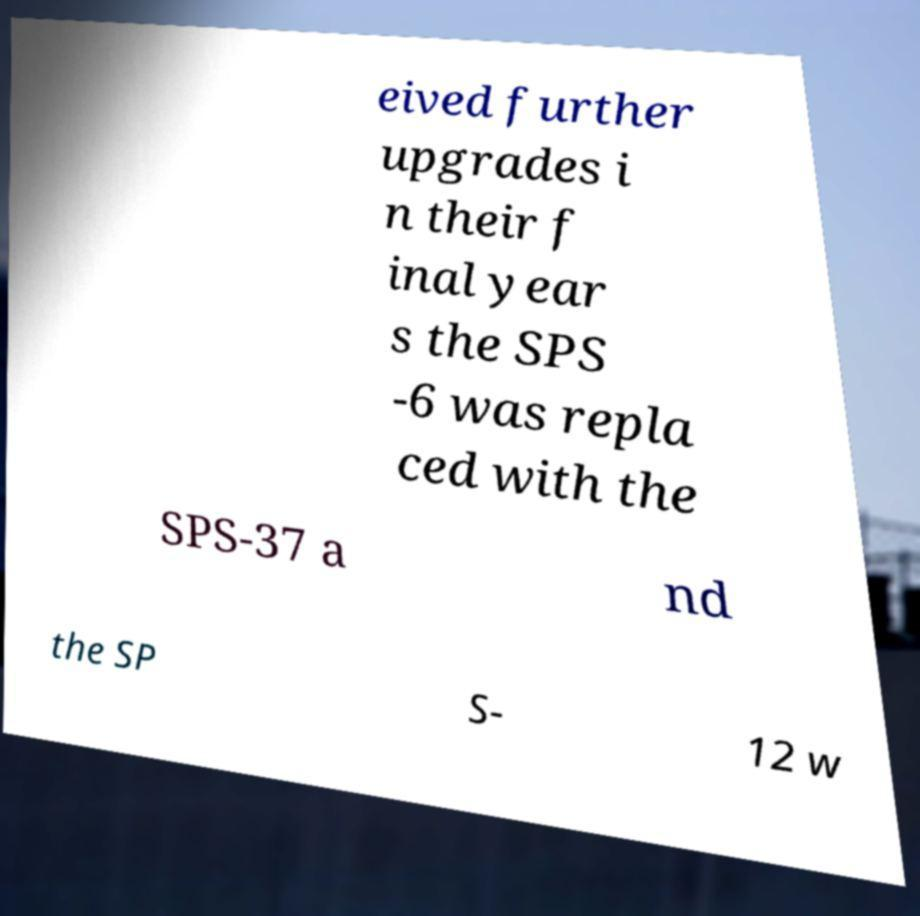Could you assist in decoding the text presented in this image and type it out clearly? eived further upgrades i n their f inal year s the SPS -6 was repla ced with the SPS-37 a nd the SP S- 12 w 